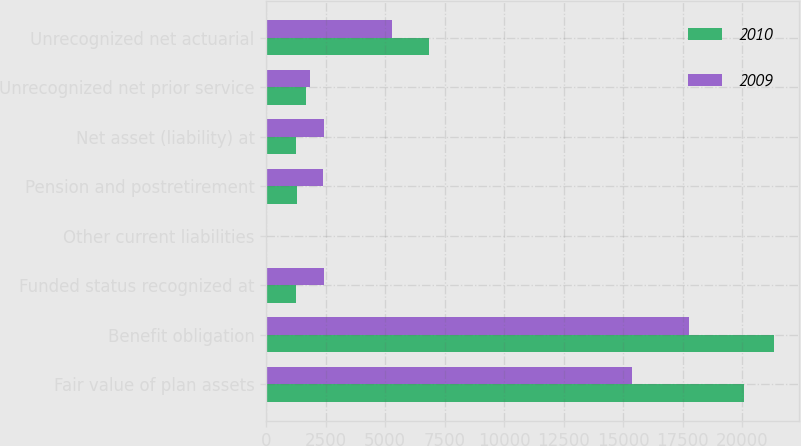<chart> <loc_0><loc_0><loc_500><loc_500><stacked_bar_chart><ecel><fcel>Fair value of plan assets<fcel>Benefit obligation<fcel>Funded status recognized at<fcel>Other current liabilities<fcel>Pension and postretirement<fcel>Net asset (liability) at<fcel>Unrecognized net prior service<fcel>Unrecognized net actuarial<nl><fcel>2010<fcel>20092<fcel>21342<fcel>1250<fcel>11<fcel>1281<fcel>1250<fcel>1660<fcel>6833<nl><fcel>2009<fcel>15351<fcel>17763<fcel>2412<fcel>11<fcel>2401<fcel>2412<fcel>1839<fcel>5289<nl></chart> 